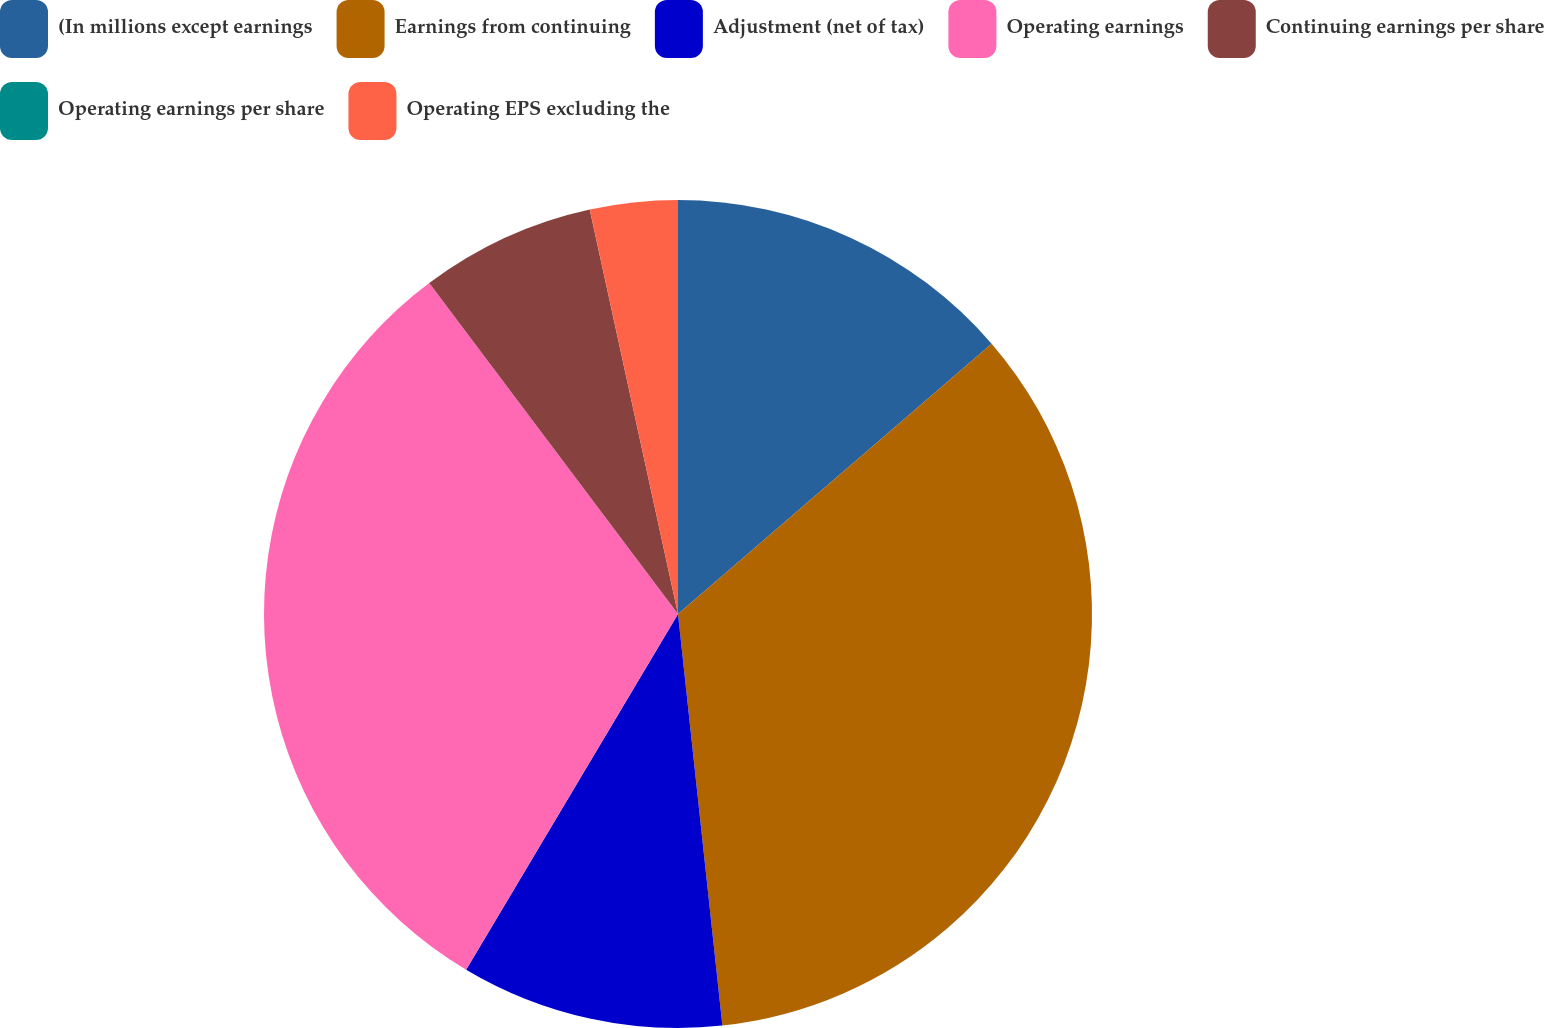Convert chart. <chart><loc_0><loc_0><loc_500><loc_500><pie_chart><fcel>(In millions except earnings<fcel>Earnings from continuing<fcel>Adjustment (net of tax)<fcel>Operating earnings<fcel>Continuing earnings per share<fcel>Operating earnings per share<fcel>Operating EPS excluding the<nl><fcel>13.68%<fcel>34.61%<fcel>10.26%<fcel>31.19%<fcel>6.84%<fcel>0.0%<fcel>3.42%<nl></chart> 